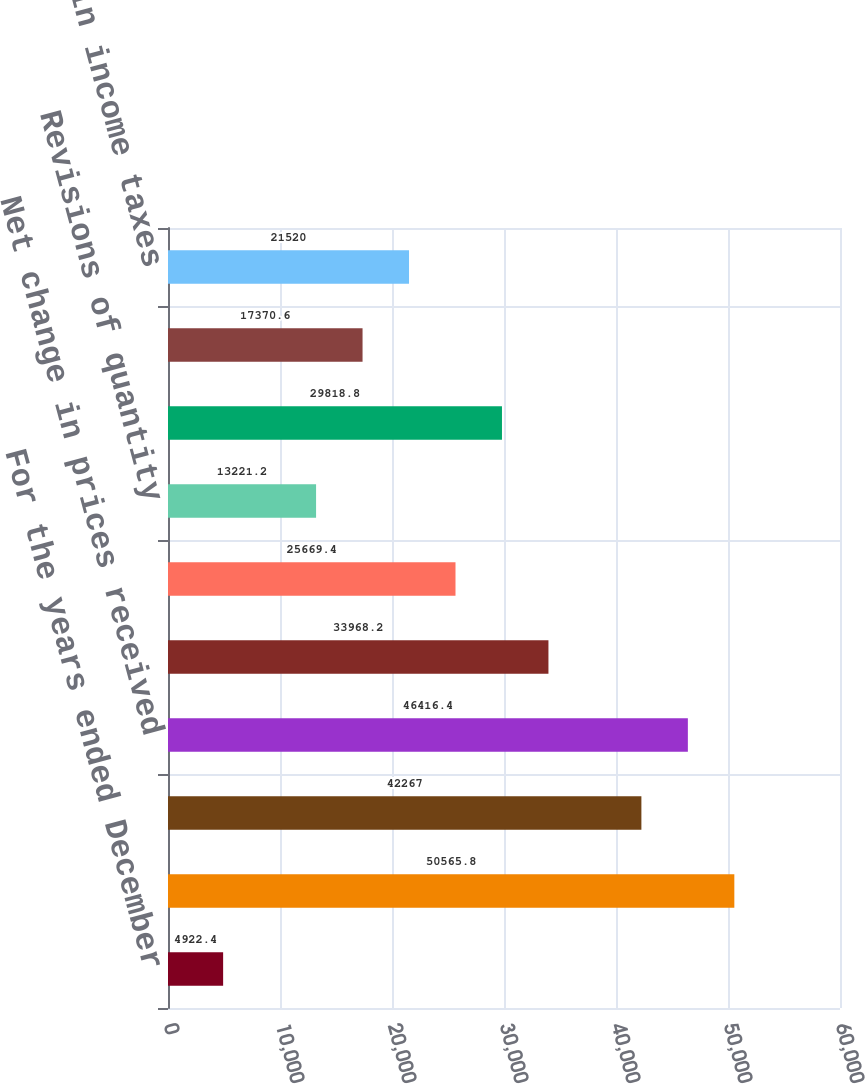Convert chart. <chart><loc_0><loc_0><loc_500><loc_500><bar_chart><fcel>For the years ended December<fcel>Beginning of year<fcel>Sales and transfers of oil and<fcel>Net change in prices received<fcel>Extensions discoveries and<fcel>Change in estimated future<fcel>Revisions of quantity<fcel>Development costs incurred<fcel>Accretion of discount<fcel>Net change in income taxes<nl><fcel>4922.4<fcel>50565.8<fcel>42267<fcel>46416.4<fcel>33968.2<fcel>25669.4<fcel>13221.2<fcel>29818.8<fcel>17370.6<fcel>21520<nl></chart> 